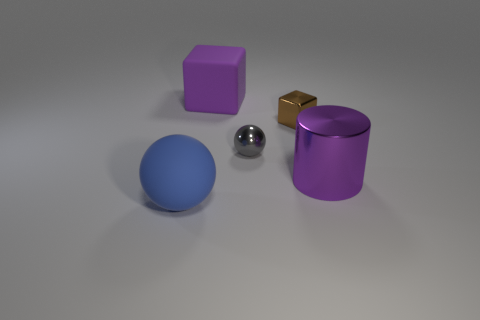Add 4 large metallic objects. How many objects exist? 9 Subtract all blue spheres. How many spheres are left? 1 Add 2 large blue spheres. How many large blue spheres are left? 3 Add 2 matte things. How many matte things exist? 4 Subtract 0 red cylinders. How many objects are left? 5 Subtract all cylinders. How many objects are left? 4 Subtract 1 balls. How many balls are left? 1 Subtract all green cylinders. Subtract all brown spheres. How many cylinders are left? 1 Subtract all purple cubes. How many gray cylinders are left? 0 Subtract all big yellow objects. Subtract all purple cubes. How many objects are left? 4 